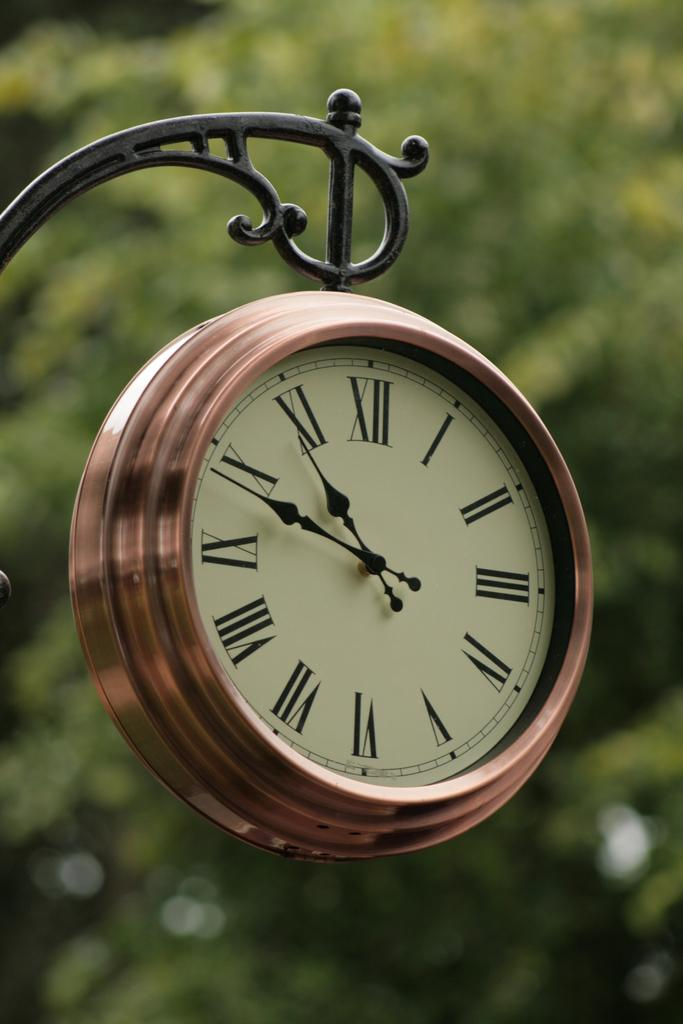What object in the image tells the time? There is a clock in the image that tells the time. How is the clock positioned in the image? The clock is hanging from a metal rod. What can be seen in the background of the image? There are trees in the background of the image. What type of cannon is being fired by the mom in the image? There is no cannon or mom present in the image; it only features a clock hanging from a metal rod and trees in the background. 